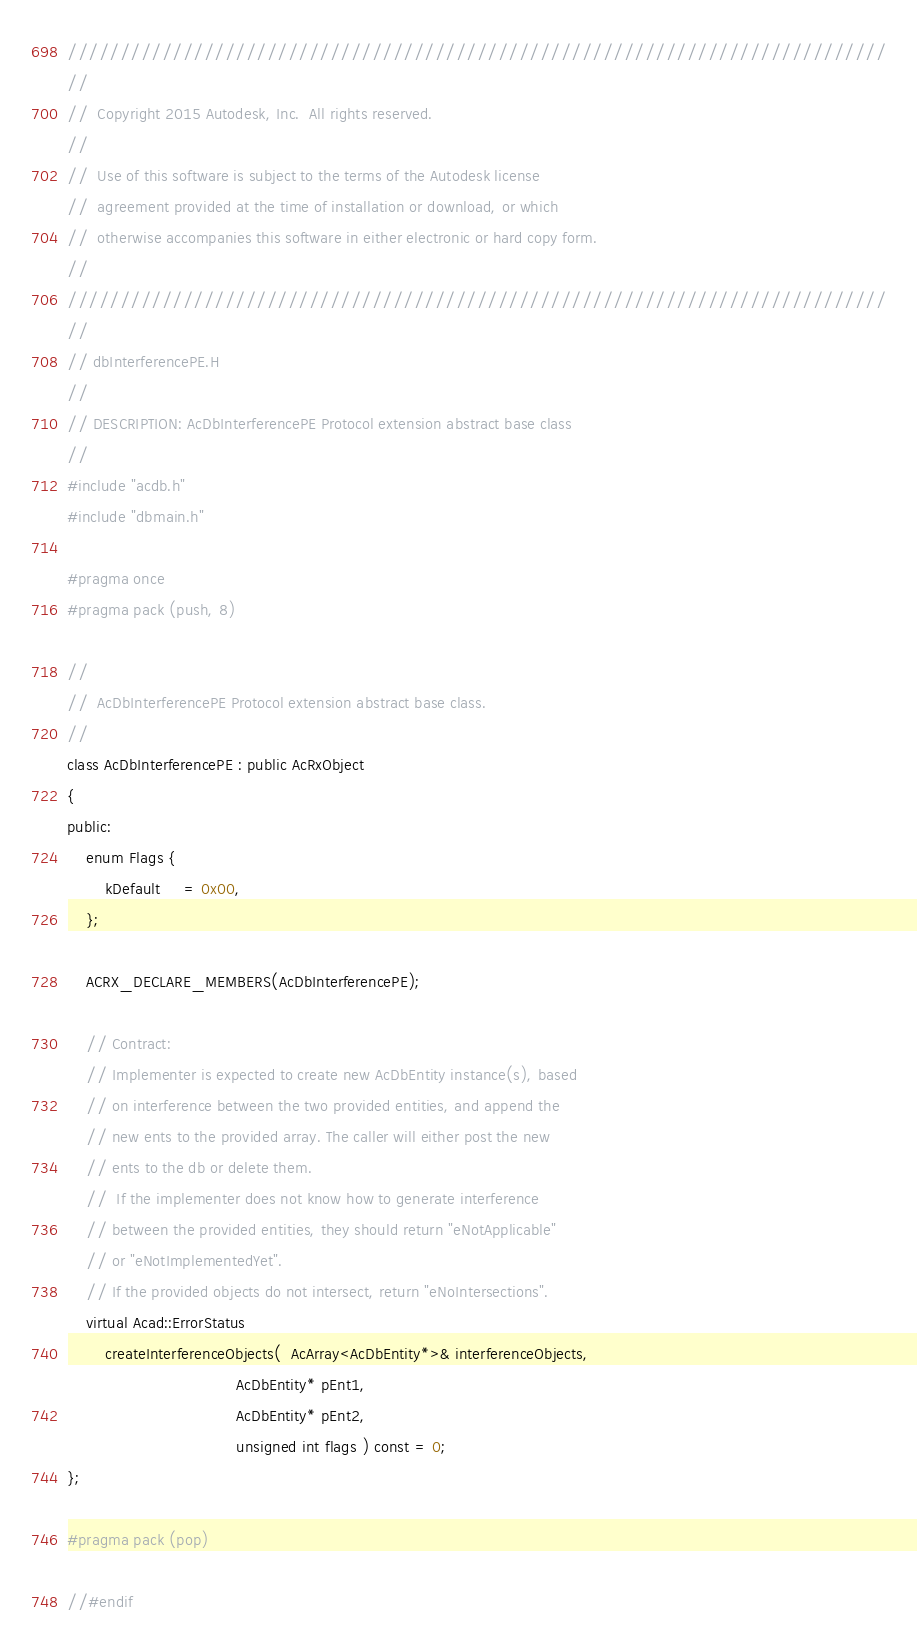<code> <loc_0><loc_0><loc_500><loc_500><_C_>//////////////////////////////////////////////////////////////////////////////
//
//  Copyright 2015 Autodesk, Inc.  All rights reserved.
//
//  Use of this software is subject to the terms of the Autodesk license 
//  agreement provided at the time of installation or download, or which 
//  otherwise accompanies this software in either electronic or hard copy form.   
//
//////////////////////////////////////////////////////////////////////////////
//
// dbInterferencePE.H
//
// DESCRIPTION: AcDbInterferencePE Protocol extension abstract base class
//
#include "acdb.h"
#include "dbmain.h"

#pragma once
#pragma pack (push, 8)

//
//  AcDbInterferencePE Protocol extension abstract base class. 
//
class AcDbInterferencePE : public AcRxObject
{
public:
    enum Flags {
        kDefault     = 0x00,
    };

    ACRX_DECLARE_MEMBERS(AcDbInterferencePE);

    // Contract:
    // Implementer is expected to create new AcDbEntity instance(s), based 
    // on interference between the two provided entities, and append the
    // new ents to the provided array. The caller will either post the new 
    // ents to the db or delete them. 
    //  If the implementer does not know how to generate interference
    // between the provided entities, they should return "eNotApplicable" 
    // or "eNotImplementedYet".
    // If the provided objects do not intersect, return "eNoIntersections".
    virtual Acad::ErrorStatus 
        createInterferenceObjects(  AcArray<AcDbEntity*>& interferenceObjects,
                                    AcDbEntity* pEnt1, 
                                    AcDbEntity* pEnt2,
                                    unsigned int flags ) const = 0;
};

#pragma pack (pop)

//#endif

</code> 